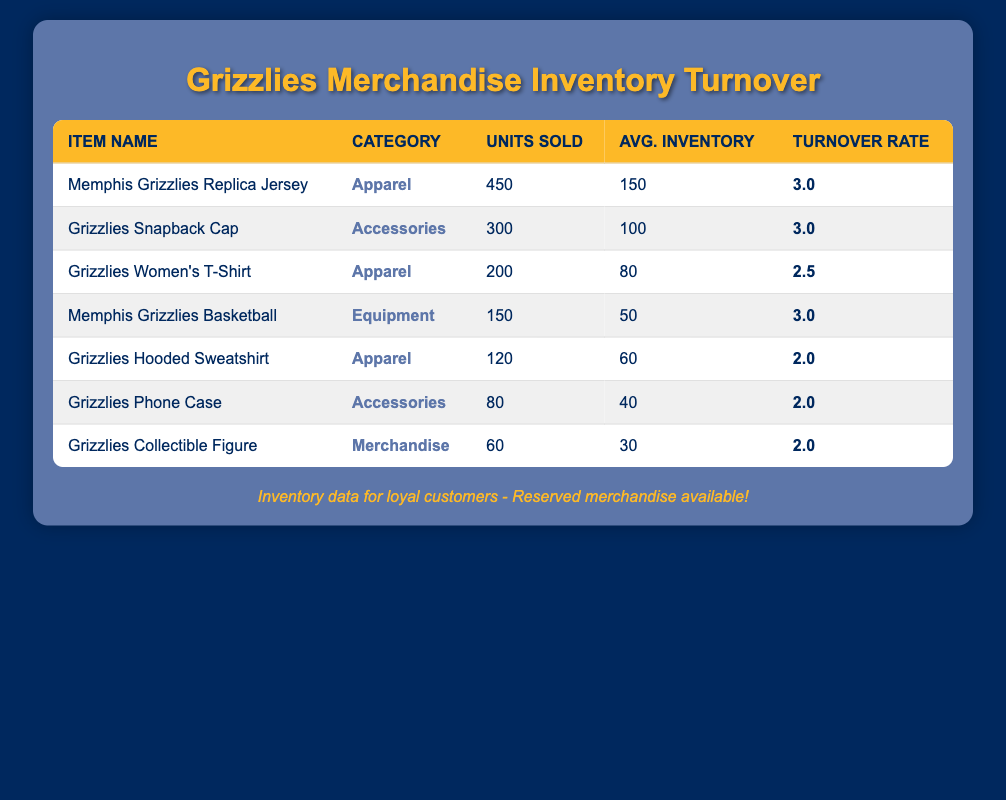What is the inventory turnover rate for the Memphis Grizzlies Replica Jersey? From the table, the inventory turnover rate for the Memphis Grizzlies Replica Jersey is listed directly beside the item name, which shows a value of 3.0.
Answer: 3.0 Which item sold the most units last quarter? By reviewing the "Total Units Sold" column, the Memphis Grizzlies Replica Jersey has the highest sales figure at 450 units, compared to other items.
Answer: Memphis Grizzlies Replica Jersey How many total units were sold for apparel items? The apparel items listed in the table are the Replica Jersey (450), Women's T-Shirt (200), and Hooded Sweatshirt (120). Adding these together (450 + 200 + 120) gives a total of 770 units sold for apparel.
Answer: 770 What is the average inventory turnover rate for all Grizzlies accessories? The inventory turnover rates for accessories are for the Snapback Cap (3.0) and Phone Case (2.0). To find the average, we sum both rates (3.0 + 2.0) = 5.0 and divide by 2, giving us 2.5.
Answer: 2.5 Is the inventory turnover rate for the Grizzlies Hooded Sweatshirt greater than or equal to 2.0? The inventory turnover rate for the Grizzlies Hooded Sweatshirt is directly available in the table and is listed as 2.0, which means it is equal to 2.0.
Answer: Yes Which item has the lowest total units sold? Looking at the "Total Units Sold" column, the item with the lowest sales is the Grizzlies Collectible Figure with just 60 units sold.
Answer: Grizzlies Collectible Figure How does the average inventory of the Grizzlies Phone Case compare to the Memphis Grizzlies Basketball? The average inventory for the Phone Case is 40, while for the Basketball, it is 50. Since 40 is less than 50, we conclude the Phone Case has a lower average inventory than the Basketball.
Answer: Lower What is the difference in total units sold between the Grizzlies Snapback Cap and the Grizzlies Hooded Sweatshirt? The Snapback Cap sold 300 units and the Hooded Sweatshirt sold 120 units. The difference is calculated by subtracting the units sold of the Hooded Sweatshirt from the Snapback Cap (300 - 120) = 180 units.
Answer: 180 What percentage of total units sold does the Memphis Grizzlies Basketball represent? The total units sold across all items can be summed up: 450 + 300 + 200 + 150 + 120 + 80 + 60 = 1360. The Basketball sold 150 units. The percentage is calculated as (150 / 1360) * 100, which is approximately 11.03%.
Answer: 11.03% 